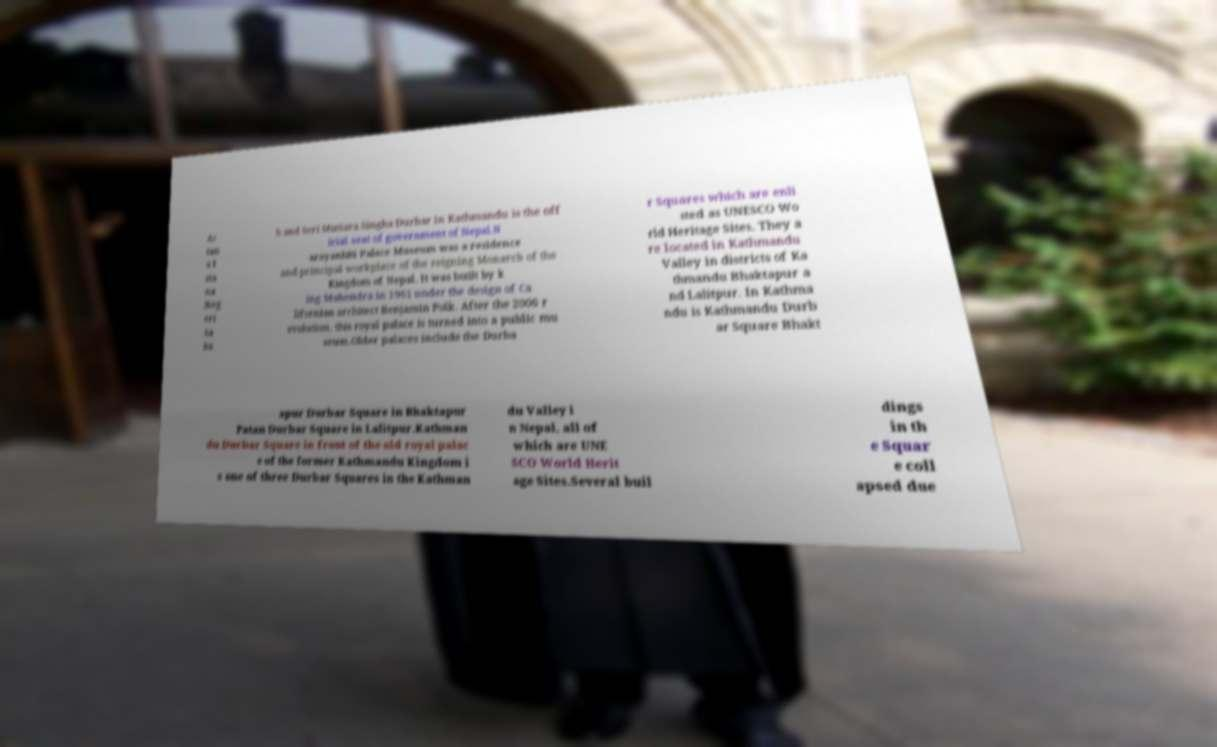Could you assist in decoding the text presented in this image and type it out clearly? As tan a I sta na Neg eri Sa ba h and Seri Mutiara.Singha Durbar in Kathmandu is the off icial seat of government of Nepal.N arayanhiti Palace Museum was a residence and principal workplace of the reigning Monarch of the Kingdom of Nepal. It was built by k ing Mahendra in 1961 under the design of Ca lifornian architect Benjamin Polk. After the 2006 r evolution, this royal palace is turned into a public mu seum.Older palaces include the Durba r Squares which are enli sted as UNESCO Wo rld Heritage Sites. They a re located in Kathmandu Valley in districts of Ka thmandu Bhaktapur a nd Lalitpur. In Kathma ndu is Kathmandu Durb ar Square Bhakt apur Durbar Square in Bhaktapur Patan Durbar Square in Lalitpur.Kathman du Durbar Square in front of the old royal palac e of the former Kathmandu Kingdom i s one of three Durbar Squares in the Kathman du Valley i n Nepal, all of which are UNE SCO World Herit age Sites.Several buil dings in th e Squar e coll apsed due 